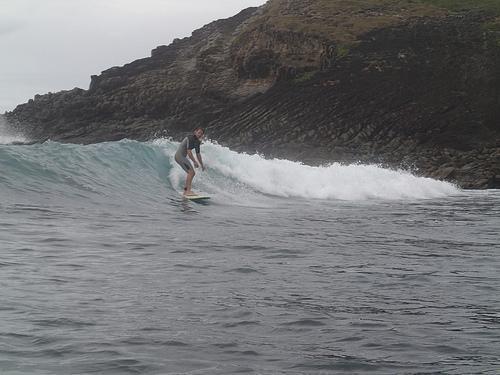How many people are surfing?
Give a very brief answer. 1. How many rocks are in picture?
Give a very brief answer. 1. 